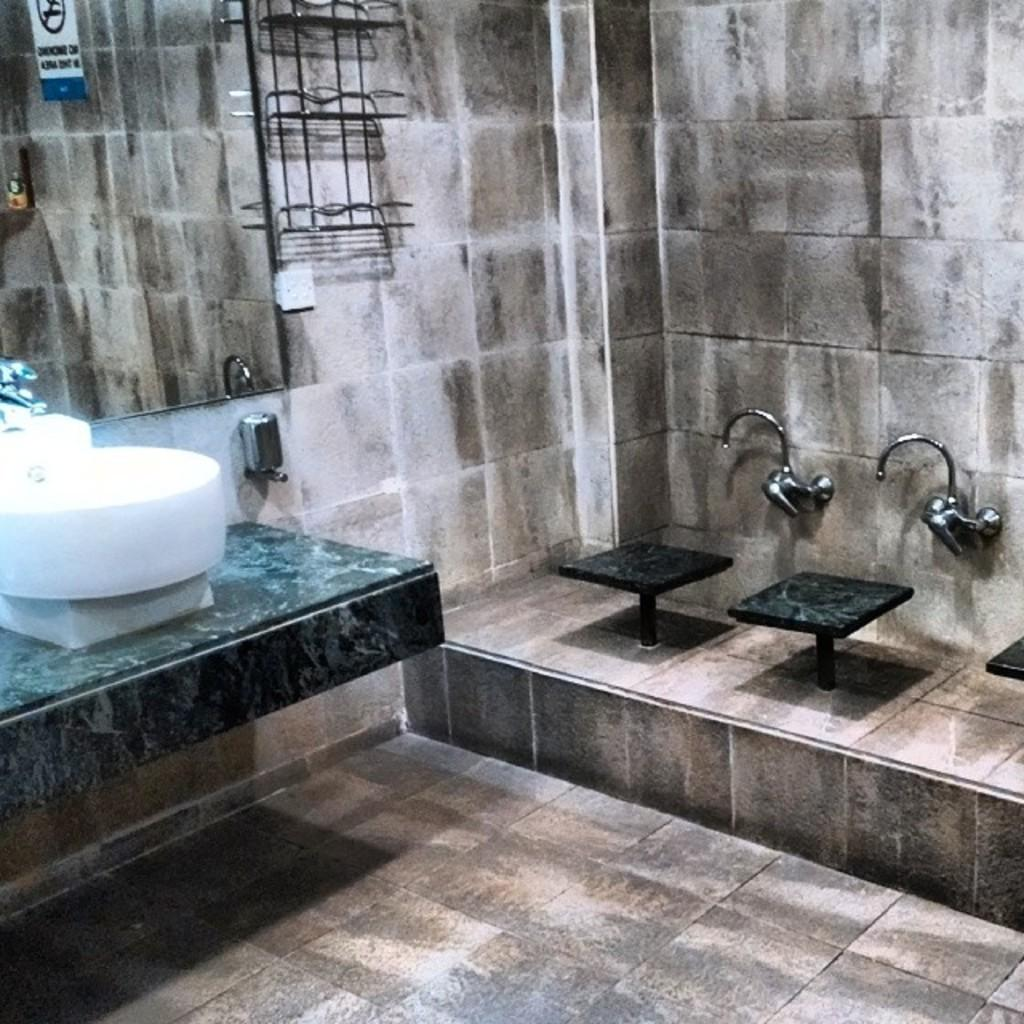What type of room is depicted in the image? The image is of a restroom. What is attached to the wall in the image? There is a mirror on the wall in the image. What type of furniture is present in the image? There are stools in the image. What can be used for washing hands in the image? There are taps and a sink in the image. Is there any additional decoration or item in the image? Yes, there is a sticker in the image. What is the distance between the restroom and the owner's house in the image? The image does not provide any information about the location or distance to the owner's house, as it only shows a restroom. How does the restroom transport people to different locations in the image? The restroom is not a mode of transportation and does not transport people to different locations; it is a stationary room for personal hygiene. 